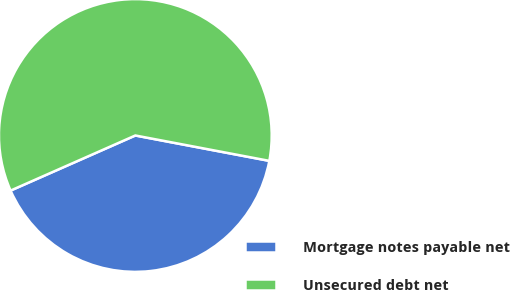Convert chart to OTSL. <chart><loc_0><loc_0><loc_500><loc_500><pie_chart><fcel>Mortgage notes payable net<fcel>Unsecured debt net<nl><fcel>40.4%<fcel>59.6%<nl></chart> 